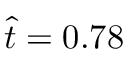Convert formula to latex. <formula><loc_0><loc_0><loc_500><loc_500>\hat { t } = 0 . 7 8</formula> 